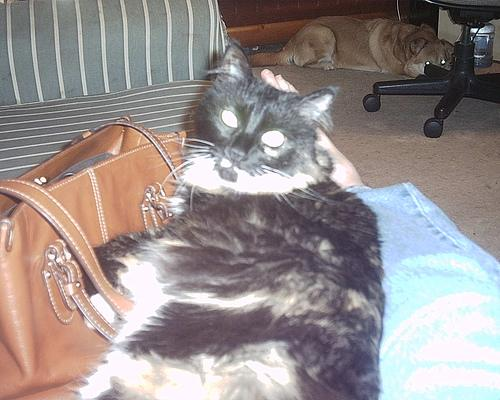What human body part does the cat lean back on? leg 